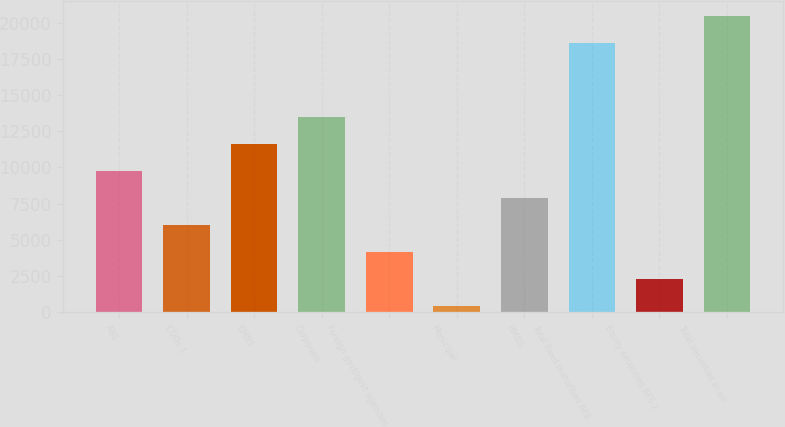Convert chart to OTSL. <chart><loc_0><loc_0><loc_500><loc_500><bar_chart><fcel>ABS<fcel>CDOs 1<fcel>CMBS<fcel>Corporate<fcel>Foreign govt/govt agencies<fcel>Municipal<fcel>RMBS<fcel>Total fixed maturities AFS<fcel>Equity securities AFS 2<fcel>Total securities in an<nl><fcel>9767.5<fcel>6036.5<fcel>11633<fcel>13498.5<fcel>4171<fcel>440<fcel>7902<fcel>18615<fcel>2305.5<fcel>20480.5<nl></chart> 